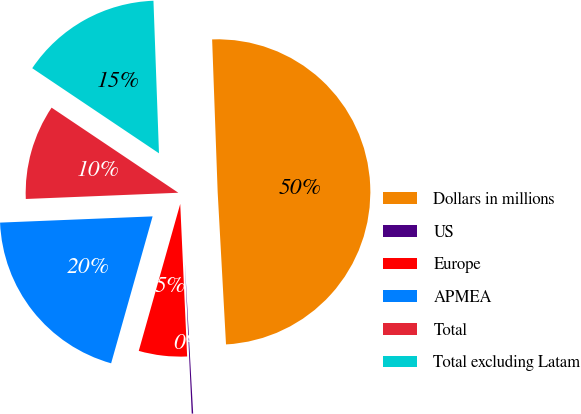<chart> <loc_0><loc_0><loc_500><loc_500><pie_chart><fcel>Dollars in millions<fcel>US<fcel>Europe<fcel>APMEA<fcel>Total<fcel>Total excluding Latam<nl><fcel>49.7%<fcel>0.15%<fcel>5.1%<fcel>19.97%<fcel>10.06%<fcel>15.01%<nl></chart> 